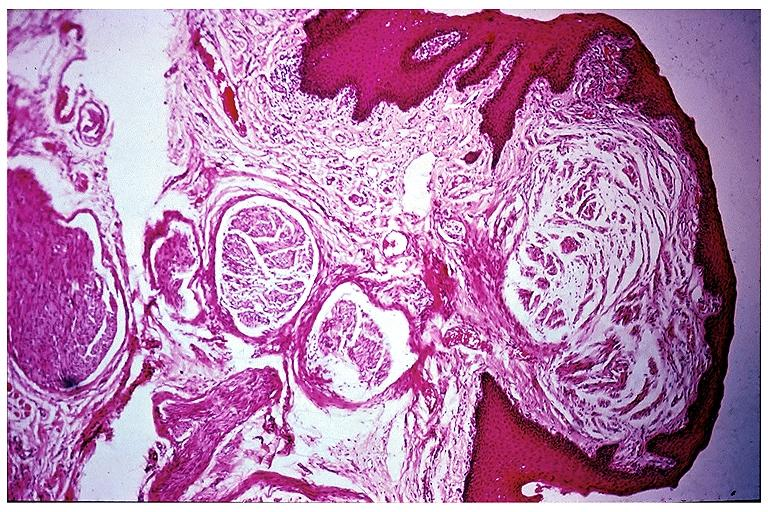s an opened peritoneal cavity cause by fibrous band strangulation present?
Answer the question using a single word or phrase. No 